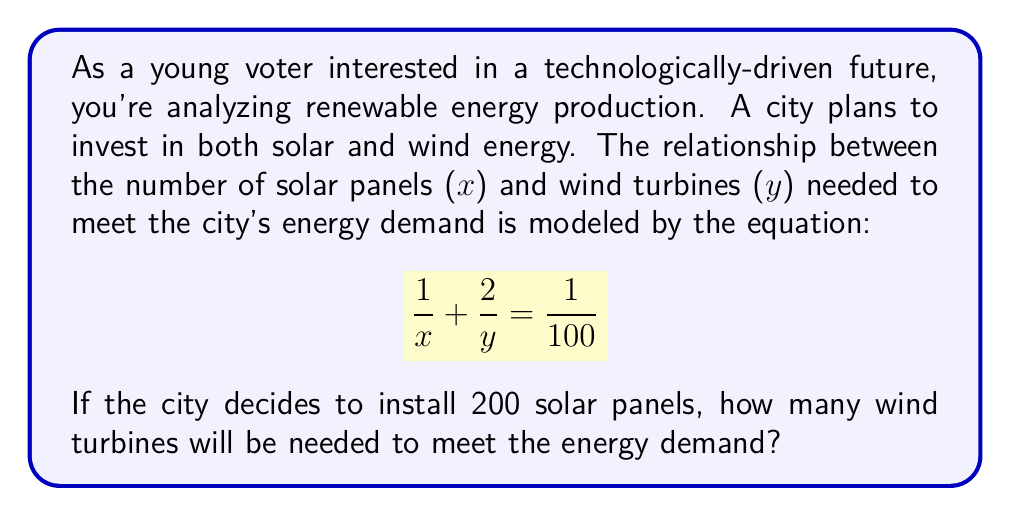Teach me how to tackle this problem. Let's solve this step-by-step:

1) We're given the equation: $$\frac{1}{x} + \frac{2}{y} = \frac{1}{100}$$

2) We know that $x = 200$ (the number of solar panels). Let's substitute this:

   $$\frac{1}{200} + \frac{2}{y} = \frac{1}{100}$$

3) Now, let's solve for $y$:
   
   First, subtract $\frac{1}{200}$ from both sides:
   
   $$\frac{2}{y} = \frac{1}{100} - \frac{1}{200}$$

4) To subtract these fractions, we need a common denominator:
   
   $$\frac{2}{y} = \frac{2}{200} - \frac{1}{200} = \frac{1}{200}$$

5) Now we have:

   $$\frac{2}{y} = \frac{1}{200}$$

6) To solve for $y$, multiply both sides by $y$ and divide by $\frac{1}{200}$:

   $$y = \frac{2}{\frac{1}{200}} = 2 * 200 = 400$$

Therefore, 400 wind turbines will be needed.
Answer: 400 wind turbines 